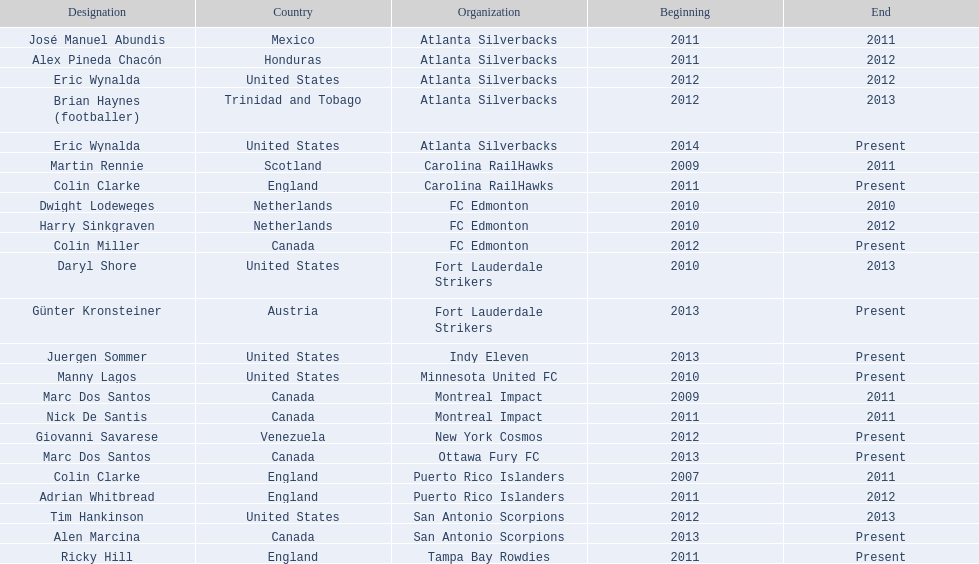Help me parse the entirety of this table. {'header': ['Designation', 'Country', 'Organization', 'Beginning', 'End'], 'rows': [['José Manuel Abundis', 'Mexico', 'Atlanta Silverbacks', '2011', '2011'], ['Alex Pineda Chacón', 'Honduras', 'Atlanta Silverbacks', '2011', '2012'], ['Eric Wynalda', 'United States', 'Atlanta Silverbacks', '2012', '2012'], ['Brian Haynes (footballer)', 'Trinidad and Tobago', 'Atlanta Silverbacks', '2012', '2013'], ['Eric Wynalda', 'United States', 'Atlanta Silverbacks', '2014', 'Present'], ['Martin Rennie', 'Scotland', 'Carolina RailHawks', '2009', '2011'], ['Colin Clarke', 'England', 'Carolina RailHawks', '2011', 'Present'], ['Dwight Lodeweges', 'Netherlands', 'FC Edmonton', '2010', '2010'], ['Harry Sinkgraven', 'Netherlands', 'FC Edmonton', '2010', '2012'], ['Colin Miller', 'Canada', 'FC Edmonton', '2012', 'Present'], ['Daryl Shore', 'United States', 'Fort Lauderdale Strikers', '2010', '2013'], ['Günter Kronsteiner', 'Austria', 'Fort Lauderdale Strikers', '2013', 'Present'], ['Juergen Sommer', 'United States', 'Indy Eleven', '2013', 'Present'], ['Manny Lagos', 'United States', 'Minnesota United FC', '2010', 'Present'], ['Marc Dos Santos', 'Canada', 'Montreal Impact', '2009', '2011'], ['Nick De Santis', 'Canada', 'Montreal Impact', '2011', '2011'], ['Giovanni Savarese', 'Venezuela', 'New York Cosmos', '2012', 'Present'], ['Marc Dos Santos', 'Canada', 'Ottawa Fury FC', '2013', 'Present'], ['Colin Clarke', 'England', 'Puerto Rico Islanders', '2007', '2011'], ['Adrian Whitbread', 'England', 'Puerto Rico Islanders', '2011', '2012'], ['Tim Hankinson', 'United States', 'San Antonio Scorpions', '2012', '2013'], ['Alen Marcina', 'Canada', 'San Antonio Scorpions', '2013', 'Present'], ['Ricky Hill', 'England', 'Tampa Bay Rowdies', '2011', 'Present']]} What year did marc dos santos start as coach? 2009. Besides marc dos santos, what other coach started in 2009? Martin Rennie. 